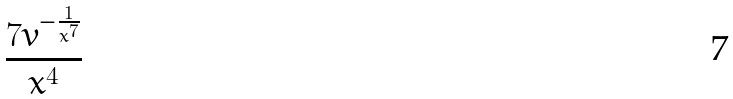<formula> <loc_0><loc_0><loc_500><loc_500>\frac { 7 v ^ { - \frac { 1 } { x ^ { 7 } } } } { x ^ { 4 } }</formula> 